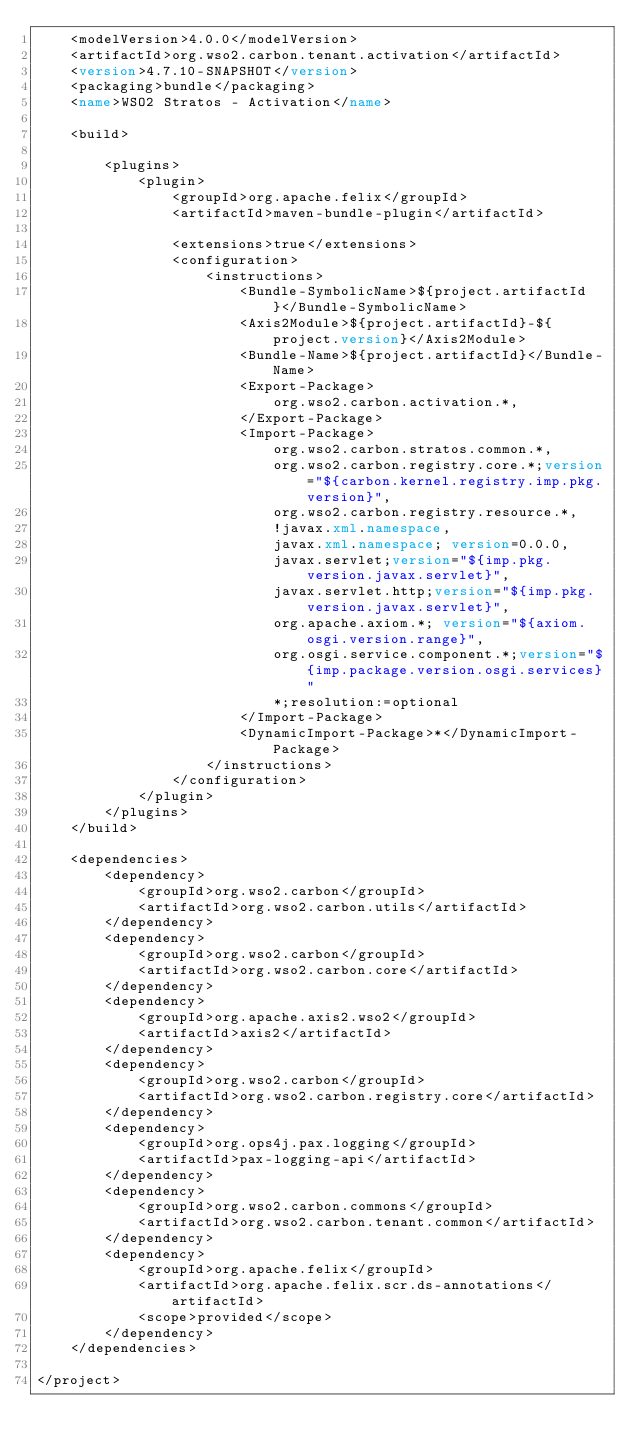Convert code to text. <code><loc_0><loc_0><loc_500><loc_500><_XML_>    <modelVersion>4.0.0</modelVersion>
    <artifactId>org.wso2.carbon.tenant.activation</artifactId>
    <version>4.7.10-SNAPSHOT</version>
    <packaging>bundle</packaging>
    <name>WSO2 Stratos - Activation</name>

    <build>

        <plugins>
            <plugin>
                <groupId>org.apache.felix</groupId>
                <artifactId>maven-bundle-plugin</artifactId>

                <extensions>true</extensions>
                <configuration>
                    <instructions>
                        <Bundle-SymbolicName>${project.artifactId}</Bundle-SymbolicName>
                        <Axis2Module>${project.artifactId}-${project.version}</Axis2Module>
                        <Bundle-Name>${project.artifactId}</Bundle-Name>
                        <Export-Package>
                            org.wso2.carbon.activation.*,
                        </Export-Package>
                        <Import-Package>
                            org.wso2.carbon.stratos.common.*,
                            org.wso2.carbon.registry.core.*;version="${carbon.kernel.registry.imp.pkg.version}",
                            org.wso2.carbon.registry.resource.*,
                            !javax.xml.namespace,
                            javax.xml.namespace; version=0.0.0,
                            javax.servlet;version="${imp.pkg.version.javax.servlet}",
                            javax.servlet.http;version="${imp.pkg.version.javax.servlet}",
                            org.apache.axiom.*; version="${axiom.osgi.version.range}",
                            org.osgi.service.component.*;version="${imp.package.version.osgi.services}"
                            *;resolution:=optional
                        </Import-Package>
                        <DynamicImport-Package>*</DynamicImport-Package>
                    </instructions>
                </configuration>
            </plugin>
        </plugins>
    </build>

    <dependencies>
        <dependency>
            <groupId>org.wso2.carbon</groupId>
            <artifactId>org.wso2.carbon.utils</artifactId>
        </dependency>
        <dependency>
            <groupId>org.wso2.carbon</groupId>
            <artifactId>org.wso2.carbon.core</artifactId>
        </dependency>
        <dependency>
            <groupId>org.apache.axis2.wso2</groupId>
            <artifactId>axis2</artifactId>
        </dependency>
        <dependency>
            <groupId>org.wso2.carbon</groupId>
            <artifactId>org.wso2.carbon.registry.core</artifactId>
        </dependency>
        <dependency>
            <groupId>org.ops4j.pax.logging</groupId>
            <artifactId>pax-logging-api</artifactId>
        </dependency>
        <dependency>
            <groupId>org.wso2.carbon.commons</groupId>
            <artifactId>org.wso2.carbon.tenant.common</artifactId>
        </dependency>
        <dependency>
            <groupId>org.apache.felix</groupId>
            <artifactId>org.apache.felix.scr.ds-annotations</artifactId>
            <scope>provided</scope>
        </dependency>
    </dependencies>

</project>
</code> 